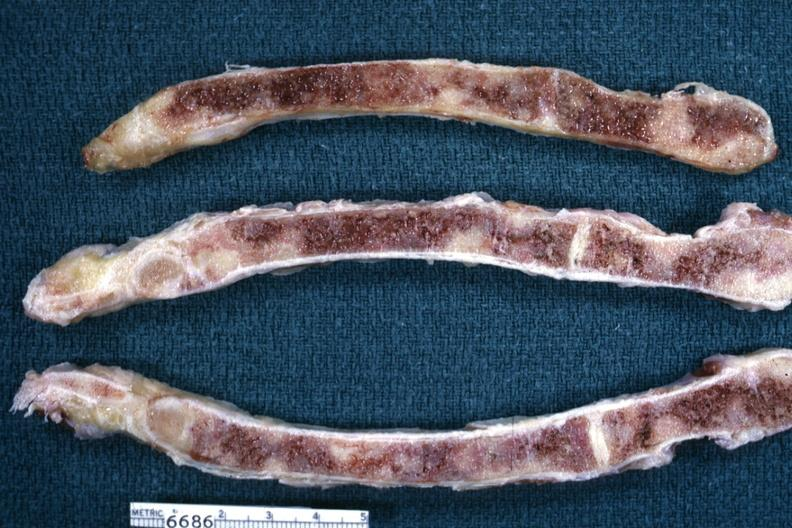what does this image show?
Answer the question using a single word or phrase. Sections of sternum with metastatic lesions from breast 